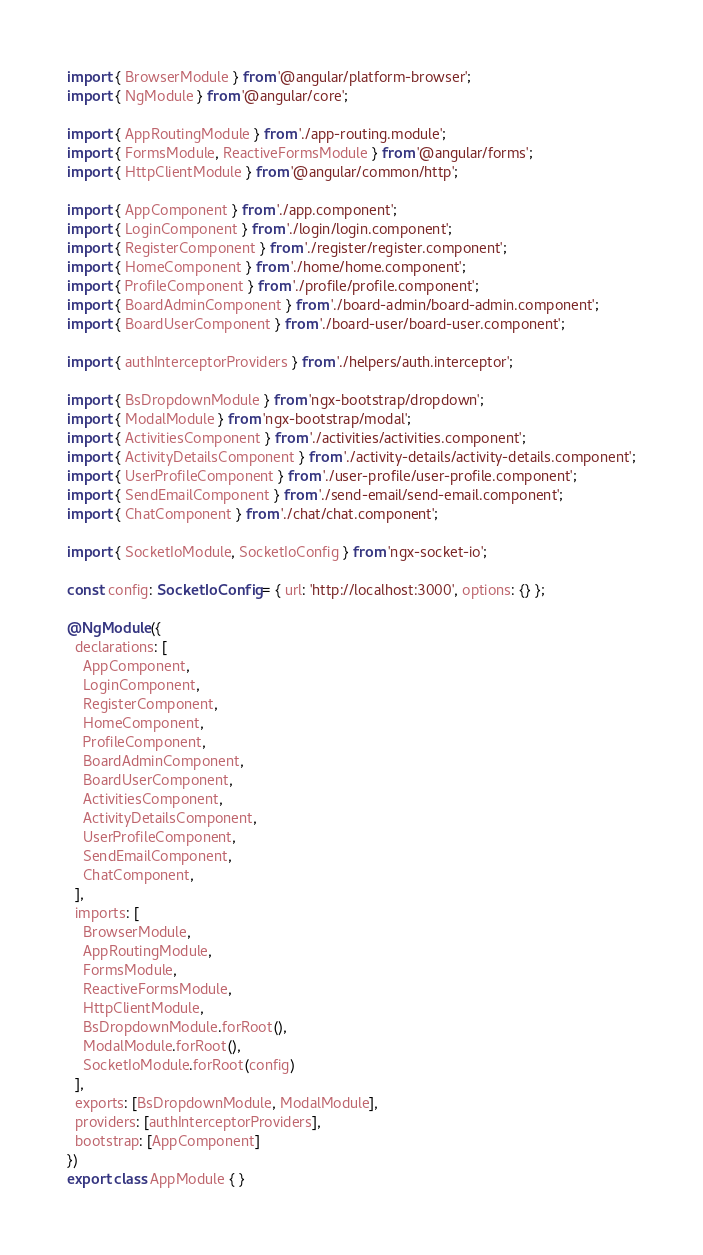Convert code to text. <code><loc_0><loc_0><loc_500><loc_500><_TypeScript_>import { BrowserModule } from '@angular/platform-browser';
import { NgModule } from '@angular/core';

import { AppRoutingModule } from './app-routing.module';
import { FormsModule, ReactiveFormsModule } from '@angular/forms';
import { HttpClientModule } from '@angular/common/http';

import { AppComponent } from './app.component';
import { LoginComponent } from './login/login.component';
import { RegisterComponent } from './register/register.component';
import { HomeComponent } from './home/home.component';
import { ProfileComponent } from './profile/profile.component';
import { BoardAdminComponent } from './board-admin/board-admin.component';
import { BoardUserComponent } from './board-user/board-user.component';

import { authInterceptorProviders } from './helpers/auth.interceptor';

import { BsDropdownModule } from 'ngx-bootstrap/dropdown';
import { ModalModule } from 'ngx-bootstrap/modal';
import { ActivitiesComponent } from './activities/activities.component';
import { ActivityDetailsComponent } from './activity-details/activity-details.component';
import { UserProfileComponent } from './user-profile/user-profile.component';
import { SendEmailComponent } from './send-email/send-email.component';
import { ChatComponent } from './chat/chat.component';

import { SocketIoModule, SocketIoConfig } from 'ngx-socket-io';

const config: SocketIoConfig = { url: 'http://localhost:3000', options: {} };

@NgModule({
  declarations: [
    AppComponent,
    LoginComponent,
    RegisterComponent,
    HomeComponent,
    ProfileComponent,
    BoardAdminComponent,
    BoardUserComponent,
    ActivitiesComponent,
    ActivityDetailsComponent,
    UserProfileComponent,
    SendEmailComponent,
    ChatComponent,
  ],
  imports: [
    BrowserModule,
    AppRoutingModule,
    FormsModule,
    ReactiveFormsModule,
    HttpClientModule,
    BsDropdownModule.forRoot(),
    ModalModule.forRoot(),
    SocketIoModule.forRoot(config)
  ],
  exports: [BsDropdownModule, ModalModule],
  providers: [authInterceptorProviders],
  bootstrap: [AppComponent]
})
export class AppModule { }
</code> 